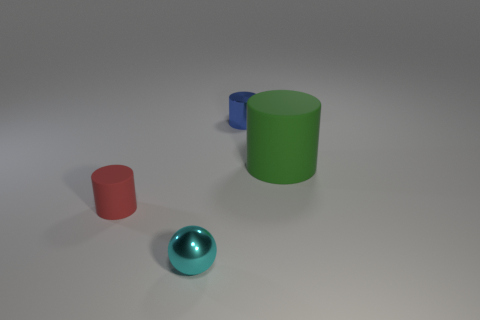Is there anything else that has the same size as the green cylinder?
Make the answer very short. No. Is there any other thing that has the same shape as the small cyan object?
Offer a terse response. No. There is a green matte cylinder; is its size the same as the rubber thing that is to the left of the small shiny ball?
Ensure brevity in your answer.  No. What number of large green objects have the same material as the small sphere?
Your response must be concise. 0. Does the green matte object have the same size as the blue metal cylinder?
Ensure brevity in your answer.  No. There is a tiny object that is behind the small sphere and in front of the tiny blue object; what is its shape?
Your answer should be compact. Cylinder. There is a rubber object to the right of the small red cylinder; what size is it?
Offer a terse response. Large. How many things are behind the metal object in front of the matte object that is left of the small blue thing?
Keep it short and to the point. 3. Are there any things to the left of the small sphere?
Ensure brevity in your answer.  Yes. What number of other objects are there of the same size as the cyan shiny thing?
Offer a very short reply. 2. 